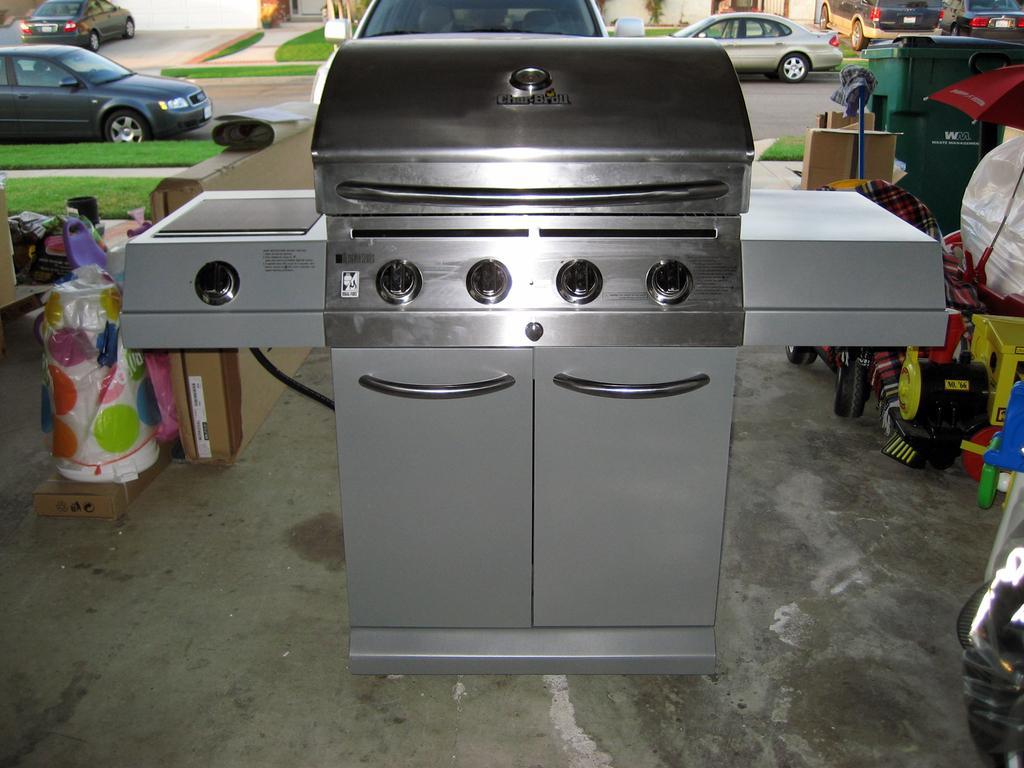Please provide a concise description of this image. Stove with cupboards. Background there is a bin, umbrella, vehicles, grass and things. 